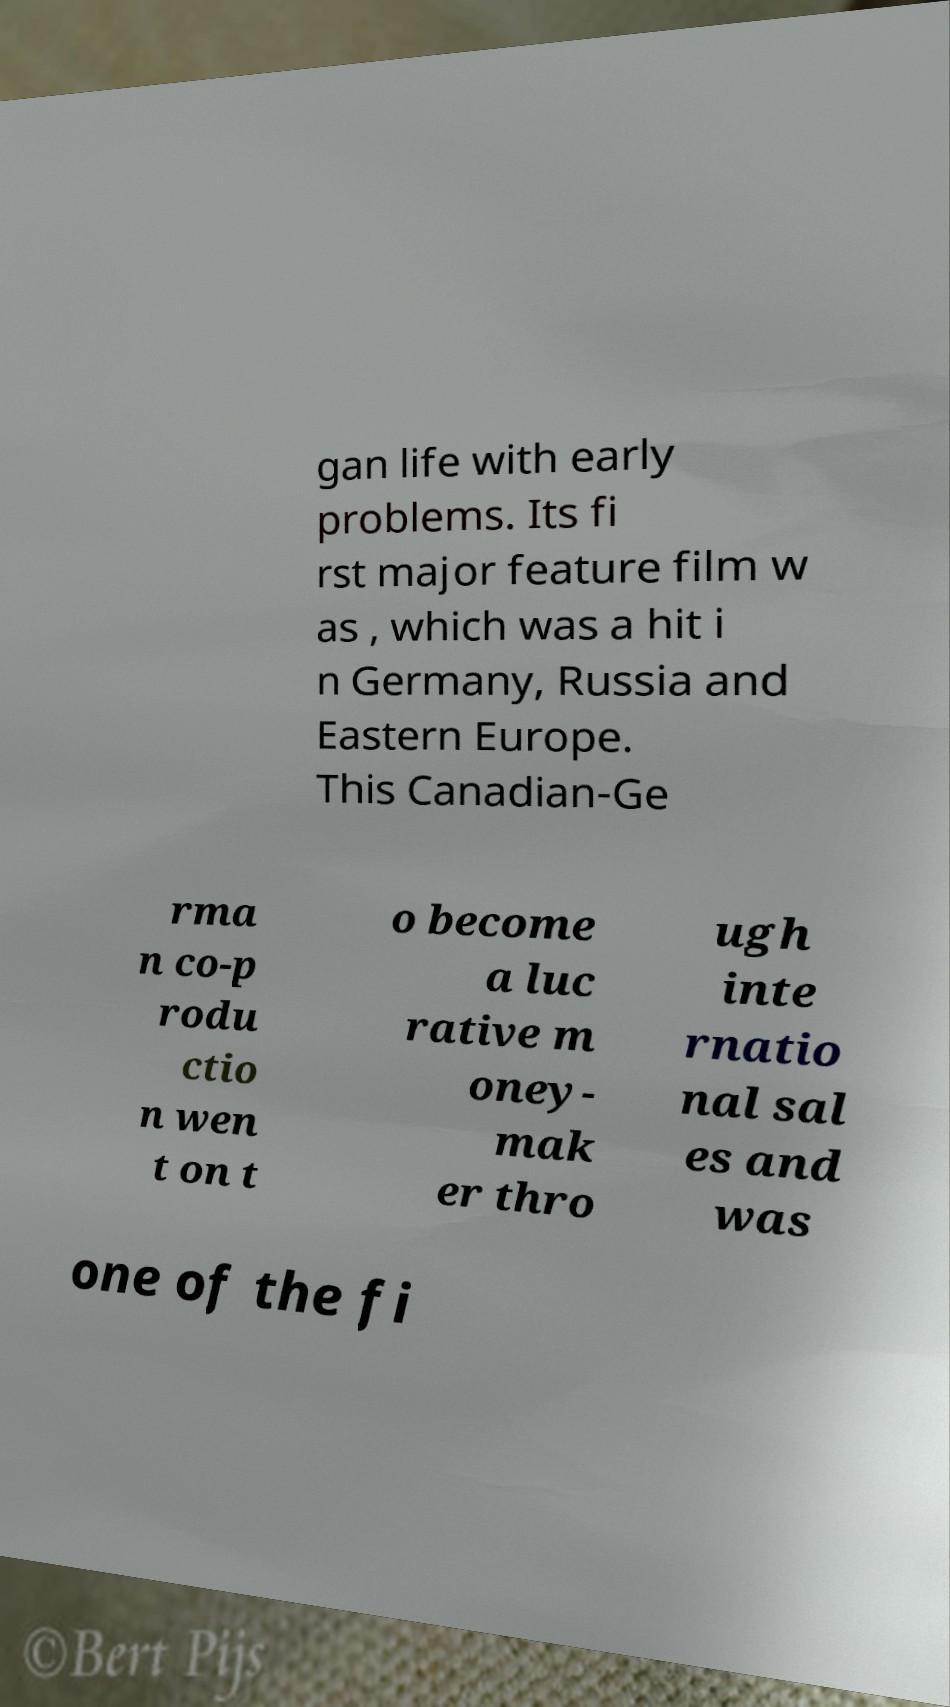Could you assist in decoding the text presented in this image and type it out clearly? gan life with early problems. Its fi rst major feature film w as , which was a hit i n Germany, Russia and Eastern Europe. This Canadian-Ge rma n co-p rodu ctio n wen t on t o become a luc rative m oney- mak er thro ugh inte rnatio nal sal es and was one of the fi 